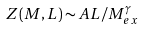Convert formula to latex. <formula><loc_0><loc_0><loc_500><loc_500>Z ( M , L ) \sim A L / M _ { e x } ^ { \gamma }</formula> 